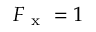Convert formula to latex. <formula><loc_0><loc_0><loc_500><loc_500>F _ { x } = 1</formula> 